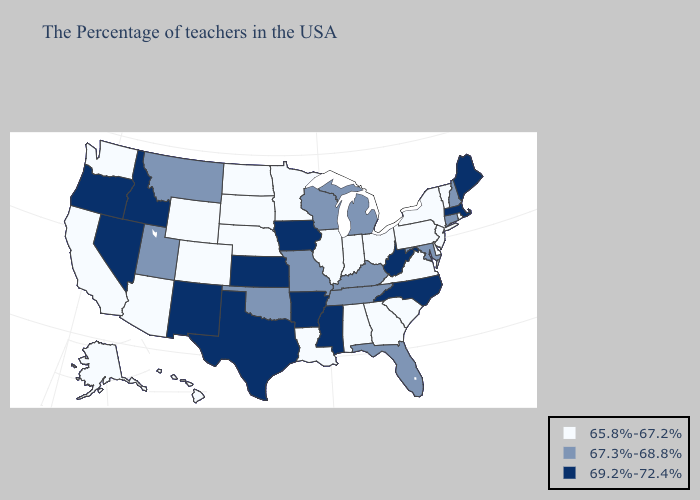What is the value of Maine?
Quick response, please. 69.2%-72.4%. Name the states that have a value in the range 67.3%-68.8%?
Give a very brief answer. New Hampshire, Connecticut, Maryland, Florida, Michigan, Kentucky, Tennessee, Wisconsin, Missouri, Oklahoma, Utah, Montana. What is the highest value in the South ?
Be succinct. 69.2%-72.4%. Name the states that have a value in the range 69.2%-72.4%?
Answer briefly. Maine, Massachusetts, North Carolina, West Virginia, Mississippi, Arkansas, Iowa, Kansas, Texas, New Mexico, Idaho, Nevada, Oregon. Does Texas have the same value as New Jersey?
Quick response, please. No. Among the states that border New Hampshire , does Vermont have the highest value?
Short answer required. No. What is the value of North Dakota?
Short answer required. 65.8%-67.2%. What is the highest value in states that border Utah?
Answer briefly. 69.2%-72.4%. Does Indiana have the highest value in the USA?
Answer briefly. No. Among the states that border Wisconsin , which have the highest value?
Answer briefly. Iowa. Does Nevada have the highest value in the West?
Short answer required. Yes. Among the states that border Oklahoma , does Colorado have the highest value?
Answer briefly. No. What is the highest value in the South ?
Quick response, please. 69.2%-72.4%. Does Vermont have the same value as North Dakota?
Quick response, please. Yes. Name the states that have a value in the range 65.8%-67.2%?
Keep it brief. Rhode Island, Vermont, New York, New Jersey, Delaware, Pennsylvania, Virginia, South Carolina, Ohio, Georgia, Indiana, Alabama, Illinois, Louisiana, Minnesota, Nebraska, South Dakota, North Dakota, Wyoming, Colorado, Arizona, California, Washington, Alaska, Hawaii. 